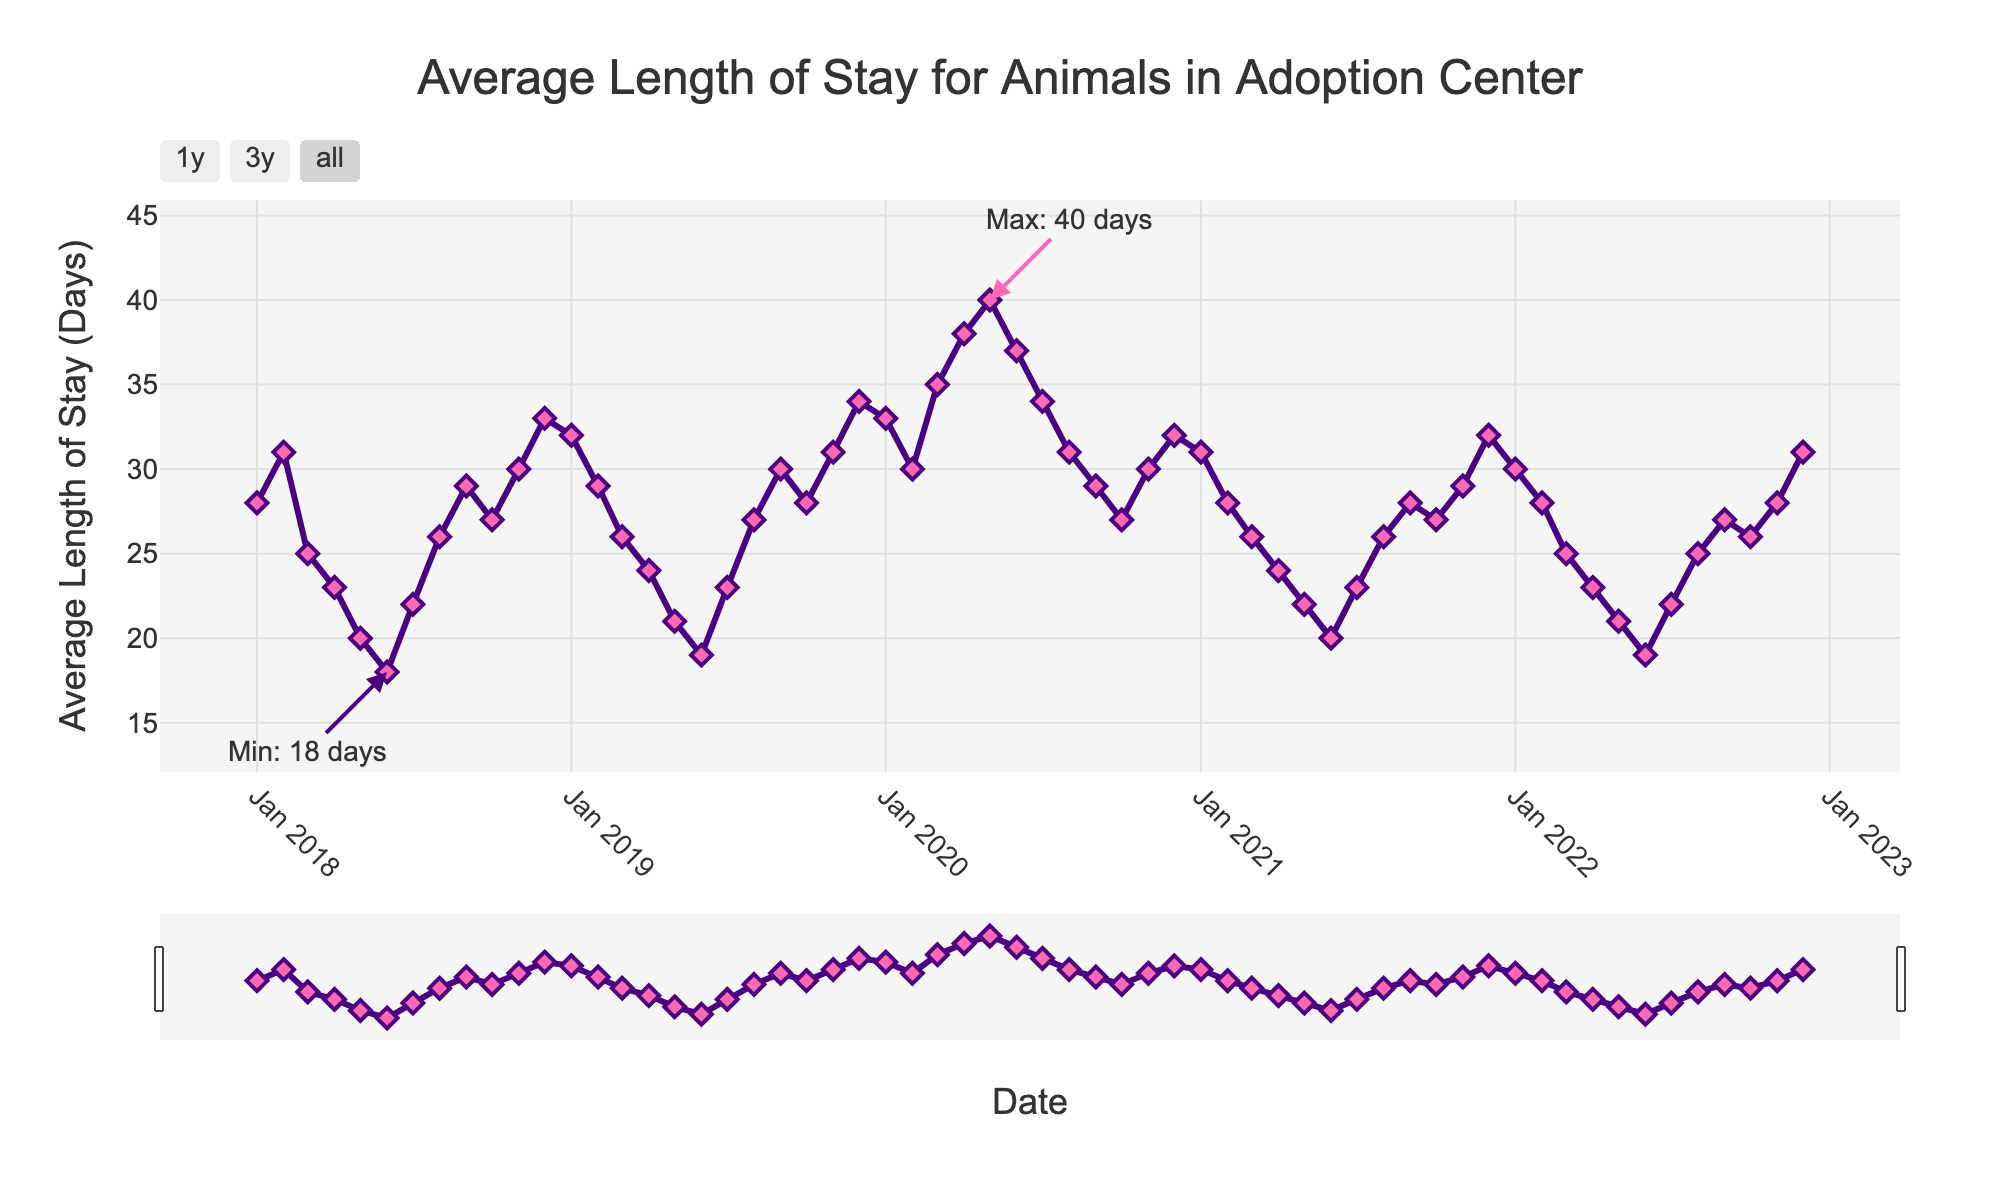What month and year had the longest average length of stay for animals? To determine the month and year with the longest average length of stay, we identify the highest point on the y-axis labeled with the stay duration. The annotation at this peak indicates the date and duration.
Answer: May 2020 How does the average length of stay in December 2018 compare to December 2020? Locate both December 2018 and December 2020 on the x-axis and note their corresponding y-values or stay durations. Then compare the two values.
Answer: 2018: 33 days, 2020: 32 days In what year did the average length of stay show the most significant increase from January to February? Determine the increase between January and February for each year by subtracting the January value from the February value. The year with the largest difference is the answer.
Answer: 2018 What is the trend of the average length of stay from July 2019 to July 2020? Analyze the data points from July 2019 to July 2020. Identify if the values are steadily increasing, decreasing, or fluctuating.
Answer: Increasing Which season (Winter, Spring, Summer, Fall) generally has the shortest average length of stay? Break down the average length of stay data by seasons (Winter: Dec-Feb, Spring: Mar-May, Summer: Jun-Aug, Fall: Sep-Nov). Find the average stay duration for each season and compare.
Answer: Summer What is the overall trend in the average length of stay from 2018 to 2022? Identify the general pattern of the data points from 2018 to 2022, considering any increases, decreases, or periods of stability.
Answer: General decrease Did the average length of stay peak during a particular season in any of the years? Look for the highest annotation points in the data and note the month and season at each peak value.
Answer: Spring 2020 By how many days did the average length of stay change from April 2020 to May 2020? Subtract the average length of stay for April 2020 from the average length of stay for May 2020.
Answer: 2 days What was the average length of stay for animals in the adoption center in August of each year from 2018 to 2022? Locate the data points for August in each year and note the corresponding y-values.
Answer: 2018: 26 days, 2019: 27 days, 2020: 31 days, 2021: 26 days, 2022: 25 days 